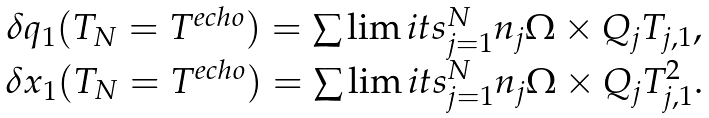<formula> <loc_0><loc_0><loc_500><loc_500>\begin{array} { c } \delta { q } _ { 1 } ( T _ { N } = T ^ { e c h o } ) = \sum \lim i t s _ { j = 1 } ^ { N } { n _ { j } { \Omega } \times { Q } _ { j } } T _ { j , 1 } , \\ \delta { x } _ { 1 } ( T _ { N } = T ^ { e c h o } ) = \sum \lim i t s _ { j = 1 } ^ { N } { n _ { j } { \Omega } \times { Q } _ { j } } T _ { j , 1 } ^ { 2 } . \\ \end{array}</formula> 